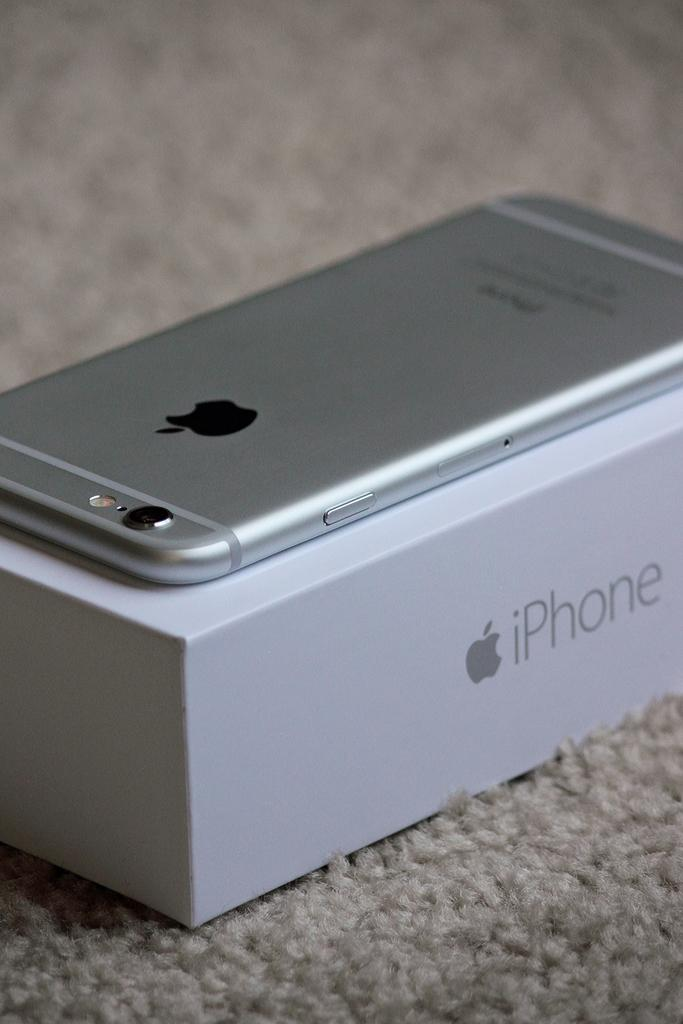<image>
Write a terse but informative summary of the picture. An iPhone sits on top of an iPhone box. 